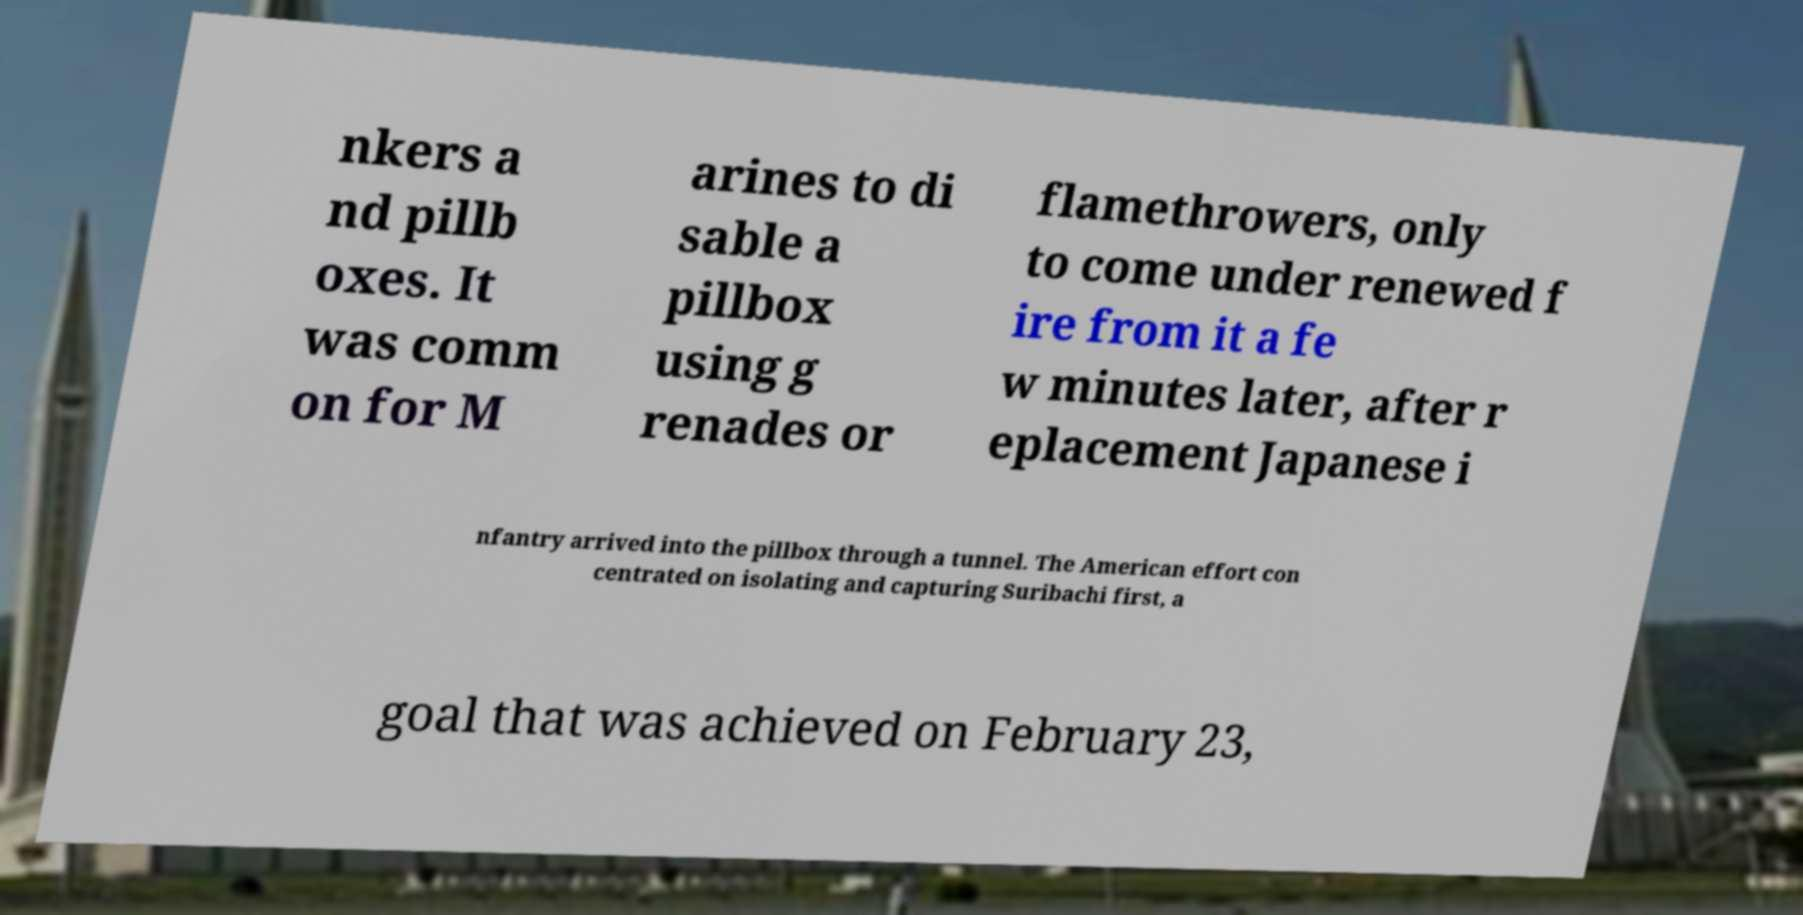Please read and relay the text visible in this image. What does it say? nkers a nd pillb oxes. It was comm on for M arines to di sable a pillbox using g renades or flamethrowers, only to come under renewed f ire from it a fe w minutes later, after r eplacement Japanese i nfantry arrived into the pillbox through a tunnel. The American effort con centrated on isolating and capturing Suribachi first, a goal that was achieved on February 23, 